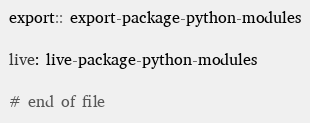<code> <loc_0><loc_0><loc_500><loc_500><_ObjectiveC_>
export:: export-package-python-modules

live: live-package-python-modules

# end of file
</code> 